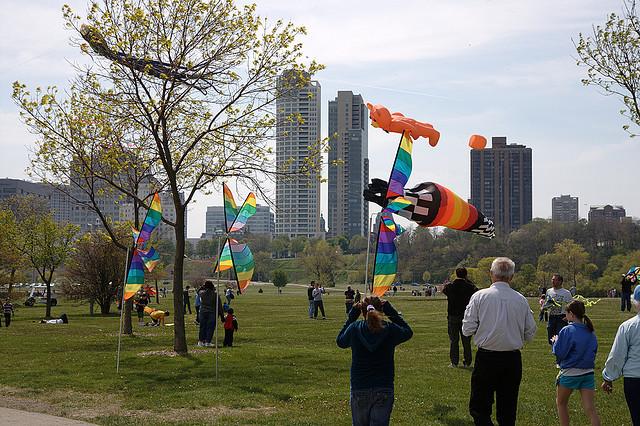How many people are laying on the grass?
Answer briefly. 1. What is flying in the air?
Give a very brief answer. Kites. What is hanging from the tree?
Keep it brief. Kite. Is there a cathedral in the background?
Answer briefly. No. How many tree's are there?
Be succinct. 5. What color is the grass?
Write a very short answer. Green. Is the kite flying?
Answer briefly. Yes. Is there a road nearby?
Answer briefly. Yes. 